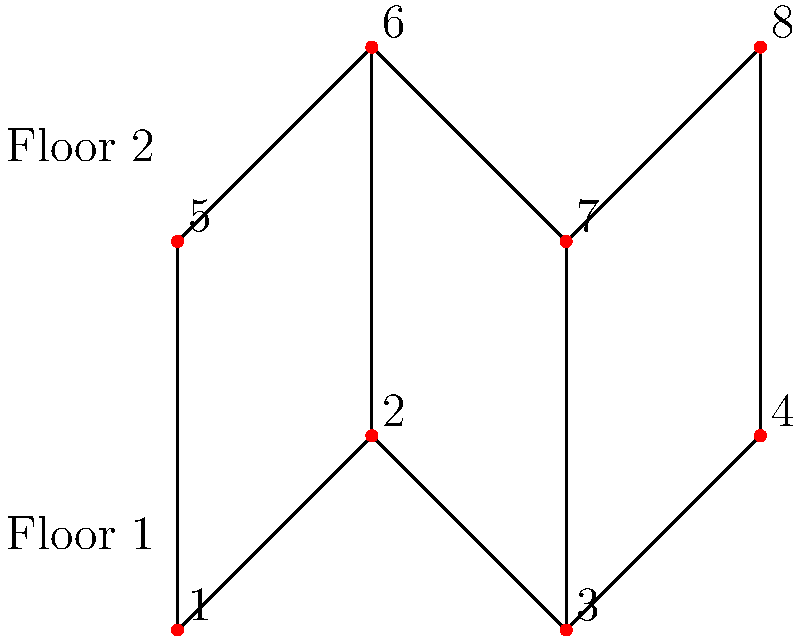In a multi-story hospital building represented as the graph above, where each vertex represents a potential location for a defibrillator and edges represent connections between locations, what is the minimum number of defibrillators needed to ensure that every location is either equipped with a defibrillator or adjacent to a location with one? (This is known as a minimum dominating set problem in graph theory.) To solve this problem, we need to find the minimum dominating set of the graph. Let's approach this step-by-step:

1) First, observe that the graph represents two floors, each with 4 locations.

2) We need to cover all 8 locations with the minimum number of defibrillators.

3) Let's start with the first floor (vertices 1-4):
   - Placing a defibrillator at vertex 2 or 3 would cover 3 vertices on the first floor.

4) For the second floor (vertices 5-8):
   - Similarly, placing a defibrillator at vertex 6 or 7 would cover 3 vertices on the second floor.

5) However, we also need to consider the vertical connections between floors:
   - If we place defibrillators at vertices 2 and 7, we cover:
     * On first floor: 1, 2, 3 (directly), and 4 (via 3)
     * On second floor: 5 (via 6), 6, 7, 8

6) Therefore, with just two defibrillators strategically placed at vertices 2 and 7, we can cover all 8 locations.

7) It's impossible to cover all vertices with fewer than 2 defibrillators because no single vertex is connected to all others.

Thus, the minimum number of defibrillators needed is 2.
Answer: 2 